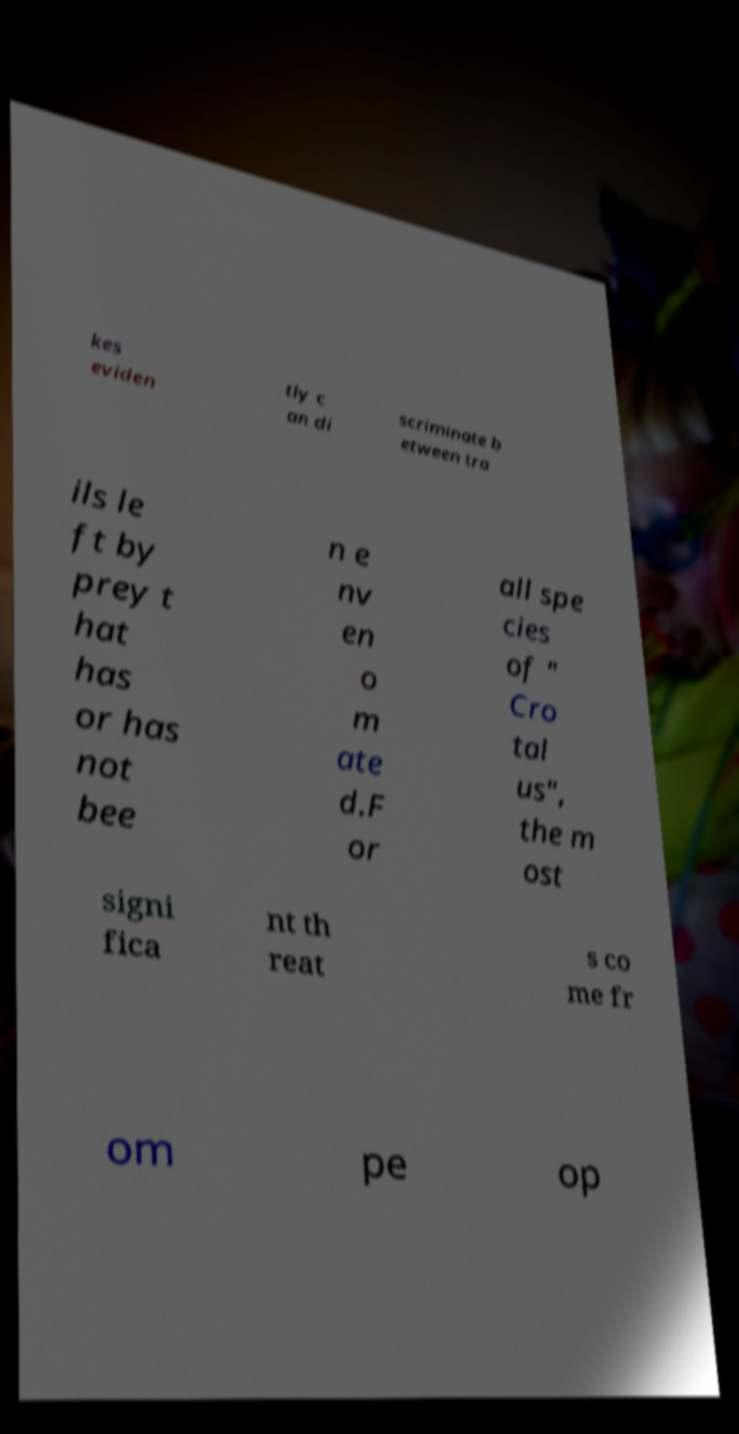I need the written content from this picture converted into text. Can you do that? kes eviden tly c an di scriminate b etween tra ils le ft by prey t hat has or has not bee n e nv en o m ate d.F or all spe cies of " Cro tal us", the m ost signi fica nt th reat s co me fr om pe op 